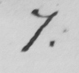Can you tell me what this handwritten text says? 7 . 